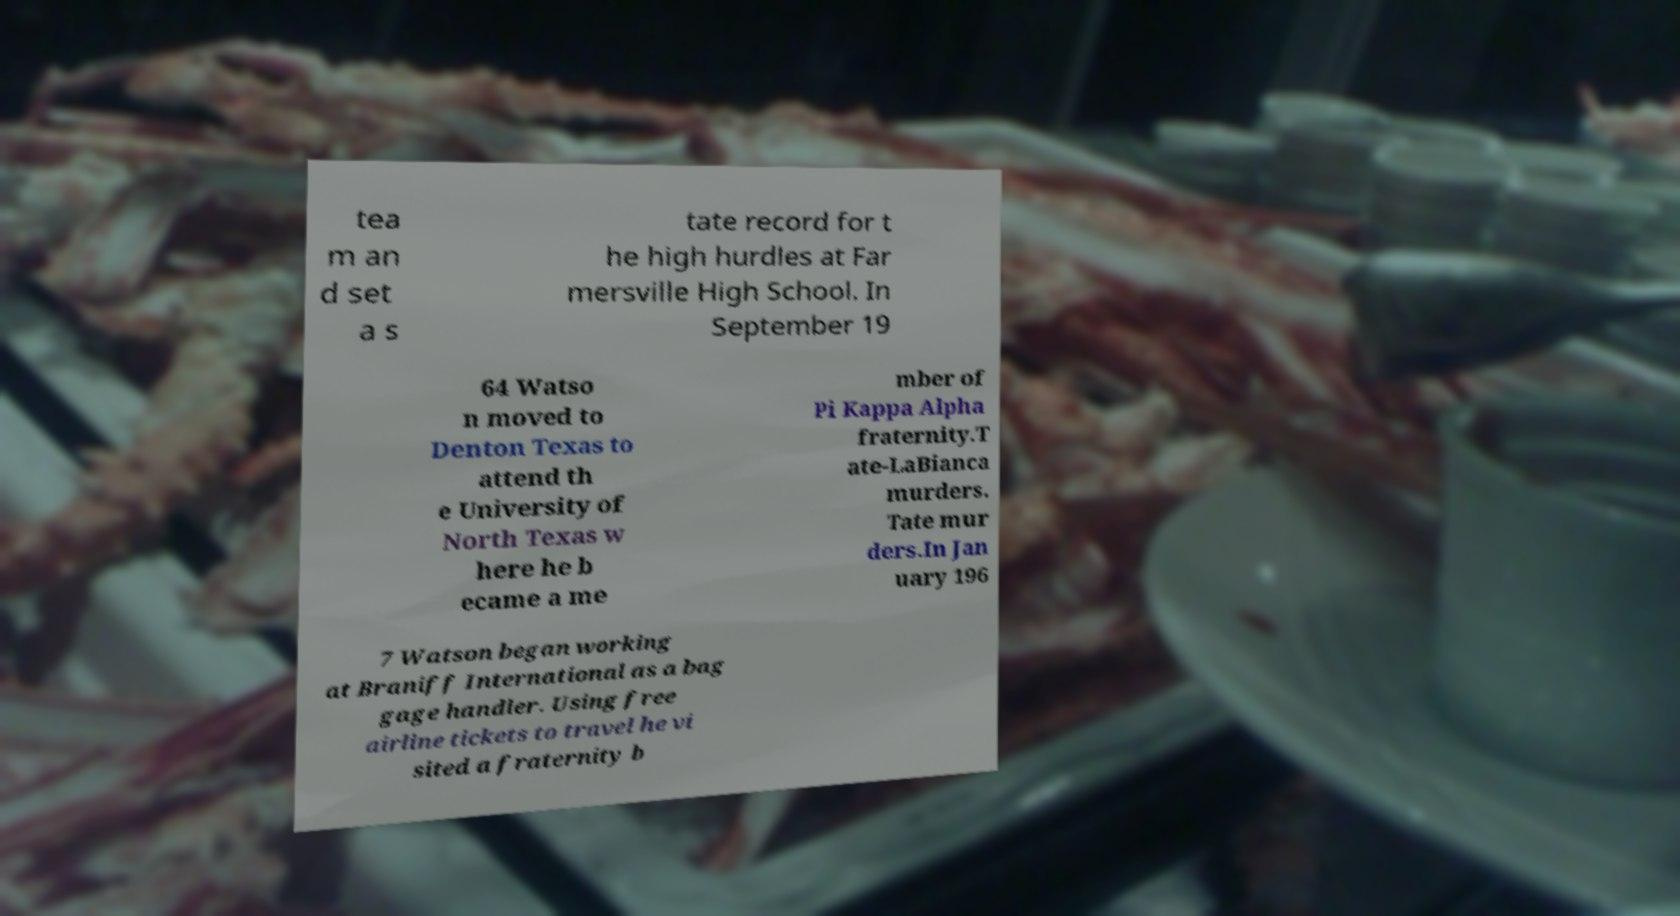I need the written content from this picture converted into text. Can you do that? tea m an d set a s tate record for t he high hurdles at Far mersville High School. In September 19 64 Watso n moved to Denton Texas to attend th e University of North Texas w here he b ecame a me mber of Pi Kappa Alpha fraternity.T ate-LaBianca murders. Tate mur ders.In Jan uary 196 7 Watson began working at Braniff International as a bag gage handler. Using free airline tickets to travel he vi sited a fraternity b 